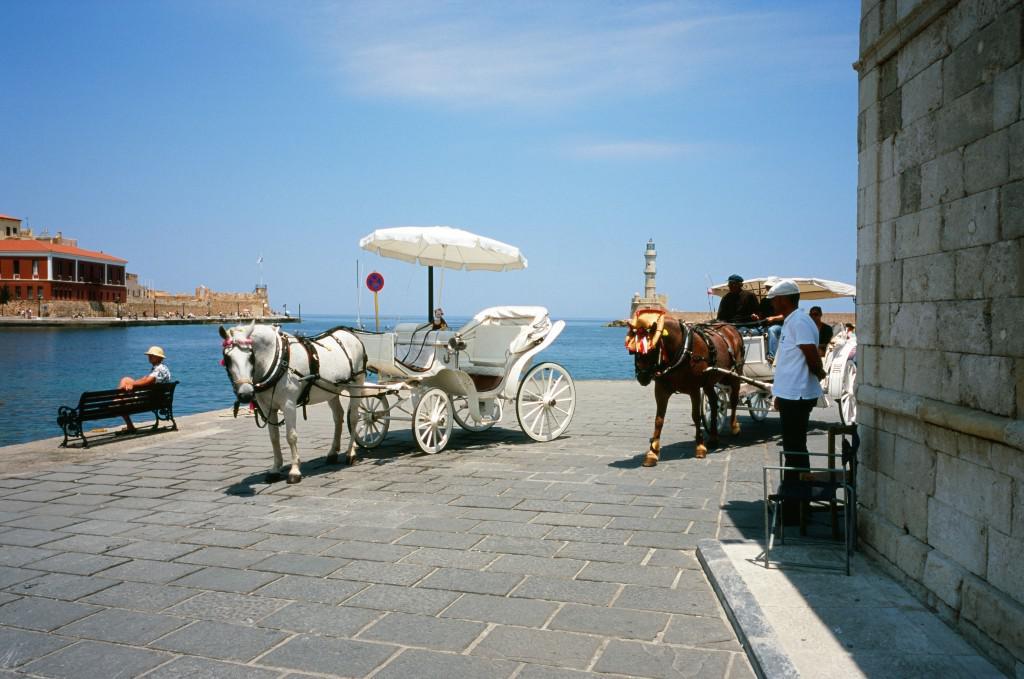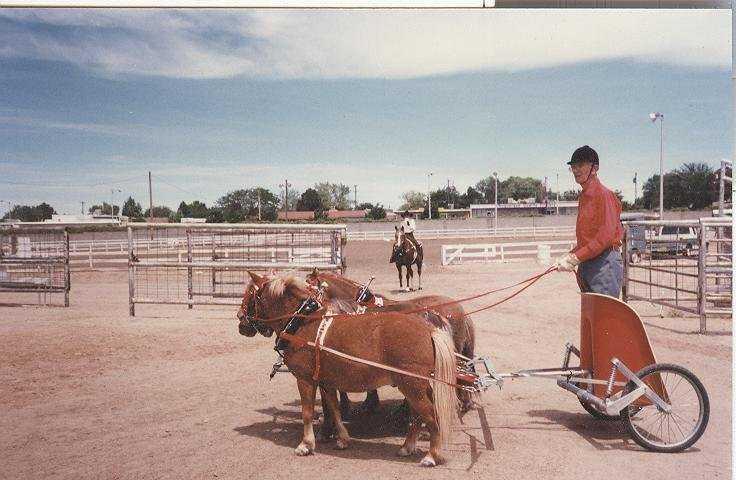The first image is the image on the left, the second image is the image on the right. For the images displayed, is the sentence "A white horse is pulling one of the carts." factually correct? Answer yes or no. Yes. The first image is the image on the left, the second image is the image on the right. Evaluate the accuracy of this statement regarding the images: "An image shows a four-wheeled horse-drawn wagon with some type of white canopy.". Is it true? Answer yes or no. Yes. 